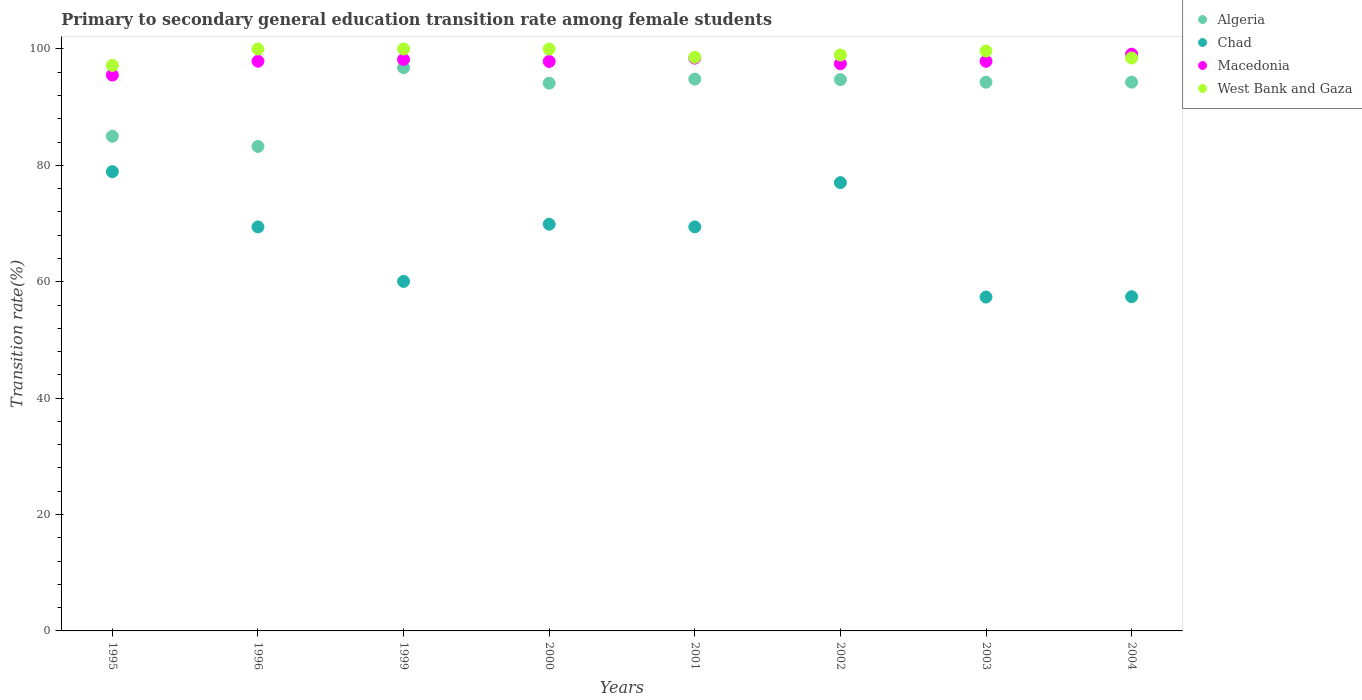How many different coloured dotlines are there?
Give a very brief answer. 4. What is the transition rate in Macedonia in 1996?
Keep it short and to the point. 97.9. Across all years, what is the minimum transition rate in Macedonia?
Provide a short and direct response. 95.51. In which year was the transition rate in Macedonia minimum?
Give a very brief answer. 1995. What is the total transition rate in Algeria in the graph?
Your response must be concise. 737.31. What is the difference between the transition rate in Macedonia in 2001 and that in 2003?
Ensure brevity in your answer.  0.54. What is the difference between the transition rate in Chad in 1995 and the transition rate in Macedonia in 2001?
Provide a succinct answer. -19.51. What is the average transition rate in Algeria per year?
Ensure brevity in your answer.  92.16. In the year 1999, what is the difference between the transition rate in Macedonia and transition rate in Algeria?
Make the answer very short. 1.42. What is the ratio of the transition rate in Macedonia in 1995 to that in 2002?
Your answer should be very brief. 0.98. Is the transition rate in West Bank and Gaza in 1995 less than that in 2003?
Make the answer very short. Yes. Is the difference between the transition rate in Macedonia in 1999 and 2001 greater than the difference between the transition rate in Algeria in 1999 and 2001?
Provide a succinct answer. No. What is the difference between the highest and the lowest transition rate in Macedonia?
Ensure brevity in your answer.  3.59. Is it the case that in every year, the sum of the transition rate in Chad and transition rate in West Bank and Gaza  is greater than the sum of transition rate in Algeria and transition rate in Macedonia?
Keep it short and to the point. No. Is it the case that in every year, the sum of the transition rate in Chad and transition rate in West Bank and Gaza  is greater than the transition rate in Algeria?
Give a very brief answer. Yes. Does the transition rate in Algeria monotonically increase over the years?
Give a very brief answer. No. Is the transition rate in Macedonia strictly greater than the transition rate in Chad over the years?
Give a very brief answer. Yes. Is the transition rate in Chad strictly less than the transition rate in Algeria over the years?
Offer a terse response. Yes. How many years are there in the graph?
Your response must be concise. 8. What is the difference between two consecutive major ticks on the Y-axis?
Your answer should be compact. 20. Are the values on the major ticks of Y-axis written in scientific E-notation?
Offer a very short reply. No. Does the graph contain any zero values?
Your answer should be compact. No. How are the legend labels stacked?
Your answer should be very brief. Vertical. What is the title of the graph?
Your answer should be very brief. Primary to secondary general education transition rate among female students. What is the label or title of the X-axis?
Your response must be concise. Years. What is the label or title of the Y-axis?
Make the answer very short. Transition rate(%). What is the Transition rate(%) of Algeria in 1995?
Keep it short and to the point. 85. What is the Transition rate(%) in Chad in 1995?
Give a very brief answer. 78.92. What is the Transition rate(%) of Macedonia in 1995?
Offer a very short reply. 95.51. What is the Transition rate(%) in West Bank and Gaza in 1995?
Keep it short and to the point. 97.18. What is the Transition rate(%) of Algeria in 1996?
Your response must be concise. 83.25. What is the Transition rate(%) in Chad in 1996?
Your response must be concise. 69.42. What is the Transition rate(%) in Macedonia in 1996?
Make the answer very short. 97.9. What is the Transition rate(%) of Algeria in 1999?
Give a very brief answer. 96.78. What is the Transition rate(%) of Chad in 1999?
Your answer should be compact. 60.06. What is the Transition rate(%) in Macedonia in 1999?
Provide a succinct answer. 98.2. What is the Transition rate(%) in West Bank and Gaza in 1999?
Offer a very short reply. 100. What is the Transition rate(%) in Algeria in 2000?
Your answer should be compact. 94.12. What is the Transition rate(%) in Chad in 2000?
Your response must be concise. 69.89. What is the Transition rate(%) in Macedonia in 2000?
Give a very brief answer. 97.86. What is the Transition rate(%) in Algeria in 2001?
Provide a succinct answer. 94.82. What is the Transition rate(%) of Chad in 2001?
Keep it short and to the point. 69.43. What is the Transition rate(%) of Macedonia in 2001?
Your response must be concise. 98.43. What is the Transition rate(%) in West Bank and Gaza in 2001?
Offer a terse response. 98.57. What is the Transition rate(%) in Algeria in 2002?
Offer a very short reply. 94.74. What is the Transition rate(%) of Chad in 2002?
Offer a very short reply. 77.03. What is the Transition rate(%) of Macedonia in 2002?
Provide a short and direct response. 97.47. What is the Transition rate(%) in West Bank and Gaza in 2002?
Offer a terse response. 98.96. What is the Transition rate(%) in Algeria in 2003?
Offer a terse response. 94.29. What is the Transition rate(%) of Chad in 2003?
Keep it short and to the point. 57.37. What is the Transition rate(%) in Macedonia in 2003?
Offer a very short reply. 97.88. What is the Transition rate(%) of West Bank and Gaza in 2003?
Offer a terse response. 99.65. What is the Transition rate(%) in Algeria in 2004?
Keep it short and to the point. 94.3. What is the Transition rate(%) in Chad in 2004?
Offer a terse response. 57.43. What is the Transition rate(%) of Macedonia in 2004?
Make the answer very short. 99.1. What is the Transition rate(%) of West Bank and Gaza in 2004?
Make the answer very short. 98.45. Across all years, what is the maximum Transition rate(%) of Algeria?
Offer a terse response. 96.78. Across all years, what is the maximum Transition rate(%) in Chad?
Your answer should be very brief. 78.92. Across all years, what is the maximum Transition rate(%) of Macedonia?
Ensure brevity in your answer.  99.1. Across all years, what is the maximum Transition rate(%) of West Bank and Gaza?
Your answer should be very brief. 100. Across all years, what is the minimum Transition rate(%) in Algeria?
Keep it short and to the point. 83.25. Across all years, what is the minimum Transition rate(%) of Chad?
Your answer should be compact. 57.37. Across all years, what is the minimum Transition rate(%) in Macedonia?
Your answer should be very brief. 95.51. Across all years, what is the minimum Transition rate(%) of West Bank and Gaza?
Your answer should be very brief. 97.18. What is the total Transition rate(%) in Algeria in the graph?
Make the answer very short. 737.31. What is the total Transition rate(%) in Chad in the graph?
Make the answer very short. 539.56. What is the total Transition rate(%) of Macedonia in the graph?
Your answer should be very brief. 782.35. What is the total Transition rate(%) of West Bank and Gaza in the graph?
Make the answer very short. 792.82. What is the difference between the Transition rate(%) in Chad in 1995 and that in 1996?
Ensure brevity in your answer.  9.5. What is the difference between the Transition rate(%) in Macedonia in 1995 and that in 1996?
Give a very brief answer. -2.39. What is the difference between the Transition rate(%) in West Bank and Gaza in 1995 and that in 1996?
Your answer should be compact. -2.82. What is the difference between the Transition rate(%) of Algeria in 1995 and that in 1999?
Ensure brevity in your answer.  -11.78. What is the difference between the Transition rate(%) in Chad in 1995 and that in 1999?
Give a very brief answer. 18.86. What is the difference between the Transition rate(%) in Macedonia in 1995 and that in 1999?
Provide a succinct answer. -2.68. What is the difference between the Transition rate(%) of West Bank and Gaza in 1995 and that in 1999?
Offer a terse response. -2.82. What is the difference between the Transition rate(%) of Algeria in 1995 and that in 2000?
Your response must be concise. -9.12. What is the difference between the Transition rate(%) of Chad in 1995 and that in 2000?
Offer a terse response. 9.03. What is the difference between the Transition rate(%) in Macedonia in 1995 and that in 2000?
Offer a terse response. -2.35. What is the difference between the Transition rate(%) in West Bank and Gaza in 1995 and that in 2000?
Offer a terse response. -2.82. What is the difference between the Transition rate(%) of Algeria in 1995 and that in 2001?
Provide a succinct answer. -9.82. What is the difference between the Transition rate(%) of Chad in 1995 and that in 2001?
Offer a terse response. 9.49. What is the difference between the Transition rate(%) of Macedonia in 1995 and that in 2001?
Your response must be concise. -2.92. What is the difference between the Transition rate(%) of West Bank and Gaza in 1995 and that in 2001?
Keep it short and to the point. -1.4. What is the difference between the Transition rate(%) of Algeria in 1995 and that in 2002?
Your answer should be compact. -9.73. What is the difference between the Transition rate(%) in Chad in 1995 and that in 2002?
Offer a very short reply. 1.88. What is the difference between the Transition rate(%) of Macedonia in 1995 and that in 2002?
Offer a terse response. -1.96. What is the difference between the Transition rate(%) in West Bank and Gaza in 1995 and that in 2002?
Keep it short and to the point. -1.79. What is the difference between the Transition rate(%) in Algeria in 1995 and that in 2003?
Give a very brief answer. -9.29. What is the difference between the Transition rate(%) of Chad in 1995 and that in 2003?
Your answer should be compact. 21.55. What is the difference between the Transition rate(%) of Macedonia in 1995 and that in 2003?
Make the answer very short. -2.37. What is the difference between the Transition rate(%) in West Bank and Gaza in 1995 and that in 2003?
Offer a very short reply. -2.48. What is the difference between the Transition rate(%) in Algeria in 1995 and that in 2004?
Your answer should be very brief. -9.3. What is the difference between the Transition rate(%) in Chad in 1995 and that in 2004?
Offer a terse response. 21.48. What is the difference between the Transition rate(%) in Macedonia in 1995 and that in 2004?
Keep it short and to the point. -3.59. What is the difference between the Transition rate(%) in West Bank and Gaza in 1995 and that in 2004?
Offer a very short reply. -1.28. What is the difference between the Transition rate(%) in Algeria in 1996 and that in 1999?
Your answer should be compact. -13.53. What is the difference between the Transition rate(%) in Chad in 1996 and that in 1999?
Provide a short and direct response. 9.36. What is the difference between the Transition rate(%) in Macedonia in 1996 and that in 1999?
Give a very brief answer. -0.3. What is the difference between the Transition rate(%) in West Bank and Gaza in 1996 and that in 1999?
Your response must be concise. 0. What is the difference between the Transition rate(%) of Algeria in 1996 and that in 2000?
Ensure brevity in your answer.  -10.87. What is the difference between the Transition rate(%) of Chad in 1996 and that in 2000?
Offer a terse response. -0.47. What is the difference between the Transition rate(%) of Macedonia in 1996 and that in 2000?
Offer a terse response. 0.04. What is the difference between the Transition rate(%) in Algeria in 1996 and that in 2001?
Your response must be concise. -11.57. What is the difference between the Transition rate(%) in Chad in 1996 and that in 2001?
Your answer should be compact. -0.01. What is the difference between the Transition rate(%) in Macedonia in 1996 and that in 2001?
Offer a very short reply. -0.53. What is the difference between the Transition rate(%) in West Bank and Gaza in 1996 and that in 2001?
Offer a very short reply. 1.43. What is the difference between the Transition rate(%) in Algeria in 1996 and that in 2002?
Give a very brief answer. -11.48. What is the difference between the Transition rate(%) in Chad in 1996 and that in 2002?
Offer a terse response. -7.61. What is the difference between the Transition rate(%) in Macedonia in 1996 and that in 2002?
Make the answer very short. 0.43. What is the difference between the Transition rate(%) of West Bank and Gaza in 1996 and that in 2002?
Ensure brevity in your answer.  1.04. What is the difference between the Transition rate(%) in Algeria in 1996 and that in 2003?
Your answer should be compact. -11.04. What is the difference between the Transition rate(%) of Chad in 1996 and that in 2003?
Offer a very short reply. 12.05. What is the difference between the Transition rate(%) in Macedonia in 1996 and that in 2003?
Ensure brevity in your answer.  0.01. What is the difference between the Transition rate(%) in West Bank and Gaza in 1996 and that in 2003?
Ensure brevity in your answer.  0.35. What is the difference between the Transition rate(%) in Algeria in 1996 and that in 2004?
Give a very brief answer. -11.05. What is the difference between the Transition rate(%) of Chad in 1996 and that in 2004?
Give a very brief answer. 11.99. What is the difference between the Transition rate(%) in Macedonia in 1996 and that in 2004?
Make the answer very short. -1.2. What is the difference between the Transition rate(%) in West Bank and Gaza in 1996 and that in 2004?
Offer a terse response. 1.55. What is the difference between the Transition rate(%) in Algeria in 1999 and that in 2000?
Provide a succinct answer. 2.66. What is the difference between the Transition rate(%) in Chad in 1999 and that in 2000?
Give a very brief answer. -9.83. What is the difference between the Transition rate(%) of Macedonia in 1999 and that in 2000?
Provide a short and direct response. 0.34. What is the difference between the Transition rate(%) in West Bank and Gaza in 1999 and that in 2000?
Keep it short and to the point. 0. What is the difference between the Transition rate(%) of Algeria in 1999 and that in 2001?
Your answer should be very brief. 1.96. What is the difference between the Transition rate(%) of Chad in 1999 and that in 2001?
Make the answer very short. -9.37. What is the difference between the Transition rate(%) in Macedonia in 1999 and that in 2001?
Your response must be concise. -0.23. What is the difference between the Transition rate(%) of West Bank and Gaza in 1999 and that in 2001?
Provide a succinct answer. 1.43. What is the difference between the Transition rate(%) in Algeria in 1999 and that in 2002?
Provide a short and direct response. 2.04. What is the difference between the Transition rate(%) of Chad in 1999 and that in 2002?
Your answer should be very brief. -16.98. What is the difference between the Transition rate(%) of Macedonia in 1999 and that in 2002?
Your answer should be compact. 0.73. What is the difference between the Transition rate(%) of West Bank and Gaza in 1999 and that in 2002?
Provide a short and direct response. 1.04. What is the difference between the Transition rate(%) in Algeria in 1999 and that in 2003?
Offer a terse response. 2.49. What is the difference between the Transition rate(%) in Chad in 1999 and that in 2003?
Offer a very short reply. 2.69. What is the difference between the Transition rate(%) in Macedonia in 1999 and that in 2003?
Your answer should be very brief. 0.31. What is the difference between the Transition rate(%) in West Bank and Gaza in 1999 and that in 2003?
Provide a short and direct response. 0.35. What is the difference between the Transition rate(%) of Algeria in 1999 and that in 2004?
Keep it short and to the point. 2.48. What is the difference between the Transition rate(%) in Chad in 1999 and that in 2004?
Offer a terse response. 2.63. What is the difference between the Transition rate(%) in Macedonia in 1999 and that in 2004?
Ensure brevity in your answer.  -0.91. What is the difference between the Transition rate(%) in West Bank and Gaza in 1999 and that in 2004?
Ensure brevity in your answer.  1.55. What is the difference between the Transition rate(%) of Algeria in 2000 and that in 2001?
Offer a very short reply. -0.7. What is the difference between the Transition rate(%) of Chad in 2000 and that in 2001?
Your response must be concise. 0.46. What is the difference between the Transition rate(%) of Macedonia in 2000 and that in 2001?
Keep it short and to the point. -0.57. What is the difference between the Transition rate(%) in West Bank and Gaza in 2000 and that in 2001?
Give a very brief answer. 1.43. What is the difference between the Transition rate(%) of Algeria in 2000 and that in 2002?
Keep it short and to the point. -0.62. What is the difference between the Transition rate(%) of Chad in 2000 and that in 2002?
Make the answer very short. -7.15. What is the difference between the Transition rate(%) in Macedonia in 2000 and that in 2002?
Make the answer very short. 0.39. What is the difference between the Transition rate(%) in West Bank and Gaza in 2000 and that in 2002?
Provide a succinct answer. 1.04. What is the difference between the Transition rate(%) of Algeria in 2000 and that in 2003?
Provide a short and direct response. -0.17. What is the difference between the Transition rate(%) in Chad in 2000 and that in 2003?
Your answer should be very brief. 12.52. What is the difference between the Transition rate(%) in Macedonia in 2000 and that in 2003?
Offer a terse response. -0.03. What is the difference between the Transition rate(%) of West Bank and Gaza in 2000 and that in 2003?
Ensure brevity in your answer.  0.35. What is the difference between the Transition rate(%) of Algeria in 2000 and that in 2004?
Offer a terse response. -0.18. What is the difference between the Transition rate(%) in Chad in 2000 and that in 2004?
Provide a short and direct response. 12.46. What is the difference between the Transition rate(%) of Macedonia in 2000 and that in 2004?
Your answer should be compact. -1.24. What is the difference between the Transition rate(%) of West Bank and Gaza in 2000 and that in 2004?
Your answer should be very brief. 1.55. What is the difference between the Transition rate(%) of Algeria in 2001 and that in 2002?
Provide a succinct answer. 0.09. What is the difference between the Transition rate(%) in Chad in 2001 and that in 2002?
Your response must be concise. -7.6. What is the difference between the Transition rate(%) in Macedonia in 2001 and that in 2002?
Your response must be concise. 0.96. What is the difference between the Transition rate(%) of West Bank and Gaza in 2001 and that in 2002?
Your answer should be compact. -0.39. What is the difference between the Transition rate(%) of Algeria in 2001 and that in 2003?
Offer a terse response. 0.53. What is the difference between the Transition rate(%) in Chad in 2001 and that in 2003?
Your answer should be very brief. 12.06. What is the difference between the Transition rate(%) of Macedonia in 2001 and that in 2003?
Your answer should be compact. 0.54. What is the difference between the Transition rate(%) in West Bank and Gaza in 2001 and that in 2003?
Ensure brevity in your answer.  -1.08. What is the difference between the Transition rate(%) of Algeria in 2001 and that in 2004?
Offer a very short reply. 0.53. What is the difference between the Transition rate(%) in Chad in 2001 and that in 2004?
Keep it short and to the point. 12. What is the difference between the Transition rate(%) in Macedonia in 2001 and that in 2004?
Give a very brief answer. -0.67. What is the difference between the Transition rate(%) in West Bank and Gaza in 2001 and that in 2004?
Your answer should be very brief. 0.12. What is the difference between the Transition rate(%) of Algeria in 2002 and that in 2003?
Provide a short and direct response. 0.45. What is the difference between the Transition rate(%) of Chad in 2002 and that in 2003?
Offer a very short reply. 19.66. What is the difference between the Transition rate(%) of Macedonia in 2002 and that in 2003?
Make the answer very short. -0.41. What is the difference between the Transition rate(%) of West Bank and Gaza in 2002 and that in 2003?
Offer a very short reply. -0.69. What is the difference between the Transition rate(%) of Algeria in 2002 and that in 2004?
Give a very brief answer. 0.44. What is the difference between the Transition rate(%) in Chad in 2002 and that in 2004?
Ensure brevity in your answer.  19.6. What is the difference between the Transition rate(%) in Macedonia in 2002 and that in 2004?
Keep it short and to the point. -1.63. What is the difference between the Transition rate(%) of West Bank and Gaza in 2002 and that in 2004?
Provide a succinct answer. 0.51. What is the difference between the Transition rate(%) in Algeria in 2003 and that in 2004?
Your answer should be very brief. -0.01. What is the difference between the Transition rate(%) of Chad in 2003 and that in 2004?
Offer a terse response. -0.06. What is the difference between the Transition rate(%) of Macedonia in 2003 and that in 2004?
Make the answer very short. -1.22. What is the difference between the Transition rate(%) in West Bank and Gaza in 2003 and that in 2004?
Keep it short and to the point. 1.2. What is the difference between the Transition rate(%) in Algeria in 1995 and the Transition rate(%) in Chad in 1996?
Your answer should be compact. 15.58. What is the difference between the Transition rate(%) of Algeria in 1995 and the Transition rate(%) of Macedonia in 1996?
Give a very brief answer. -12.9. What is the difference between the Transition rate(%) in Algeria in 1995 and the Transition rate(%) in West Bank and Gaza in 1996?
Your answer should be very brief. -15. What is the difference between the Transition rate(%) in Chad in 1995 and the Transition rate(%) in Macedonia in 1996?
Make the answer very short. -18.98. What is the difference between the Transition rate(%) in Chad in 1995 and the Transition rate(%) in West Bank and Gaza in 1996?
Offer a terse response. -21.08. What is the difference between the Transition rate(%) of Macedonia in 1995 and the Transition rate(%) of West Bank and Gaza in 1996?
Offer a terse response. -4.49. What is the difference between the Transition rate(%) of Algeria in 1995 and the Transition rate(%) of Chad in 1999?
Give a very brief answer. 24.94. What is the difference between the Transition rate(%) of Algeria in 1995 and the Transition rate(%) of Macedonia in 1999?
Your answer should be very brief. -13.19. What is the difference between the Transition rate(%) of Algeria in 1995 and the Transition rate(%) of West Bank and Gaza in 1999?
Your answer should be very brief. -15. What is the difference between the Transition rate(%) in Chad in 1995 and the Transition rate(%) in Macedonia in 1999?
Offer a very short reply. -19.28. What is the difference between the Transition rate(%) of Chad in 1995 and the Transition rate(%) of West Bank and Gaza in 1999?
Provide a succinct answer. -21.08. What is the difference between the Transition rate(%) in Macedonia in 1995 and the Transition rate(%) in West Bank and Gaza in 1999?
Offer a terse response. -4.49. What is the difference between the Transition rate(%) of Algeria in 1995 and the Transition rate(%) of Chad in 2000?
Provide a short and direct response. 15.12. What is the difference between the Transition rate(%) in Algeria in 1995 and the Transition rate(%) in Macedonia in 2000?
Offer a very short reply. -12.86. What is the difference between the Transition rate(%) of Algeria in 1995 and the Transition rate(%) of West Bank and Gaza in 2000?
Offer a terse response. -15. What is the difference between the Transition rate(%) in Chad in 1995 and the Transition rate(%) in Macedonia in 2000?
Offer a terse response. -18.94. What is the difference between the Transition rate(%) in Chad in 1995 and the Transition rate(%) in West Bank and Gaza in 2000?
Keep it short and to the point. -21.08. What is the difference between the Transition rate(%) in Macedonia in 1995 and the Transition rate(%) in West Bank and Gaza in 2000?
Offer a terse response. -4.49. What is the difference between the Transition rate(%) in Algeria in 1995 and the Transition rate(%) in Chad in 2001?
Your response must be concise. 15.57. What is the difference between the Transition rate(%) of Algeria in 1995 and the Transition rate(%) of Macedonia in 2001?
Provide a succinct answer. -13.42. What is the difference between the Transition rate(%) of Algeria in 1995 and the Transition rate(%) of West Bank and Gaza in 2001?
Offer a terse response. -13.57. What is the difference between the Transition rate(%) of Chad in 1995 and the Transition rate(%) of Macedonia in 2001?
Your response must be concise. -19.51. What is the difference between the Transition rate(%) of Chad in 1995 and the Transition rate(%) of West Bank and Gaza in 2001?
Provide a succinct answer. -19.66. What is the difference between the Transition rate(%) of Macedonia in 1995 and the Transition rate(%) of West Bank and Gaza in 2001?
Your answer should be compact. -3.06. What is the difference between the Transition rate(%) in Algeria in 1995 and the Transition rate(%) in Chad in 2002?
Provide a succinct answer. 7.97. What is the difference between the Transition rate(%) in Algeria in 1995 and the Transition rate(%) in Macedonia in 2002?
Offer a terse response. -12.47. What is the difference between the Transition rate(%) in Algeria in 1995 and the Transition rate(%) in West Bank and Gaza in 2002?
Ensure brevity in your answer.  -13.96. What is the difference between the Transition rate(%) of Chad in 1995 and the Transition rate(%) of Macedonia in 2002?
Provide a succinct answer. -18.55. What is the difference between the Transition rate(%) in Chad in 1995 and the Transition rate(%) in West Bank and Gaza in 2002?
Provide a short and direct response. -20.05. What is the difference between the Transition rate(%) of Macedonia in 1995 and the Transition rate(%) of West Bank and Gaza in 2002?
Provide a succinct answer. -3.45. What is the difference between the Transition rate(%) in Algeria in 1995 and the Transition rate(%) in Chad in 2003?
Offer a very short reply. 27.63. What is the difference between the Transition rate(%) in Algeria in 1995 and the Transition rate(%) in Macedonia in 2003?
Provide a short and direct response. -12.88. What is the difference between the Transition rate(%) of Algeria in 1995 and the Transition rate(%) of West Bank and Gaza in 2003?
Provide a succinct answer. -14.65. What is the difference between the Transition rate(%) in Chad in 1995 and the Transition rate(%) in Macedonia in 2003?
Your answer should be compact. -18.97. What is the difference between the Transition rate(%) of Chad in 1995 and the Transition rate(%) of West Bank and Gaza in 2003?
Provide a succinct answer. -20.74. What is the difference between the Transition rate(%) of Macedonia in 1995 and the Transition rate(%) of West Bank and Gaza in 2003?
Make the answer very short. -4.14. What is the difference between the Transition rate(%) in Algeria in 1995 and the Transition rate(%) in Chad in 2004?
Offer a terse response. 27.57. What is the difference between the Transition rate(%) of Algeria in 1995 and the Transition rate(%) of Macedonia in 2004?
Give a very brief answer. -14.1. What is the difference between the Transition rate(%) in Algeria in 1995 and the Transition rate(%) in West Bank and Gaza in 2004?
Your answer should be very brief. -13.45. What is the difference between the Transition rate(%) in Chad in 1995 and the Transition rate(%) in Macedonia in 2004?
Provide a short and direct response. -20.19. What is the difference between the Transition rate(%) of Chad in 1995 and the Transition rate(%) of West Bank and Gaza in 2004?
Your answer should be very brief. -19.54. What is the difference between the Transition rate(%) in Macedonia in 1995 and the Transition rate(%) in West Bank and Gaza in 2004?
Your answer should be compact. -2.94. What is the difference between the Transition rate(%) of Algeria in 1996 and the Transition rate(%) of Chad in 1999?
Offer a terse response. 23.19. What is the difference between the Transition rate(%) in Algeria in 1996 and the Transition rate(%) in Macedonia in 1999?
Provide a short and direct response. -14.94. What is the difference between the Transition rate(%) in Algeria in 1996 and the Transition rate(%) in West Bank and Gaza in 1999?
Offer a very short reply. -16.75. What is the difference between the Transition rate(%) in Chad in 1996 and the Transition rate(%) in Macedonia in 1999?
Give a very brief answer. -28.77. What is the difference between the Transition rate(%) in Chad in 1996 and the Transition rate(%) in West Bank and Gaza in 1999?
Your response must be concise. -30.58. What is the difference between the Transition rate(%) of Macedonia in 1996 and the Transition rate(%) of West Bank and Gaza in 1999?
Make the answer very short. -2.1. What is the difference between the Transition rate(%) in Algeria in 1996 and the Transition rate(%) in Chad in 2000?
Offer a very short reply. 13.37. What is the difference between the Transition rate(%) of Algeria in 1996 and the Transition rate(%) of Macedonia in 2000?
Make the answer very short. -14.61. What is the difference between the Transition rate(%) in Algeria in 1996 and the Transition rate(%) in West Bank and Gaza in 2000?
Provide a succinct answer. -16.75. What is the difference between the Transition rate(%) of Chad in 1996 and the Transition rate(%) of Macedonia in 2000?
Keep it short and to the point. -28.44. What is the difference between the Transition rate(%) of Chad in 1996 and the Transition rate(%) of West Bank and Gaza in 2000?
Offer a very short reply. -30.58. What is the difference between the Transition rate(%) in Macedonia in 1996 and the Transition rate(%) in West Bank and Gaza in 2000?
Provide a short and direct response. -2.1. What is the difference between the Transition rate(%) in Algeria in 1996 and the Transition rate(%) in Chad in 2001?
Make the answer very short. 13.82. What is the difference between the Transition rate(%) of Algeria in 1996 and the Transition rate(%) of Macedonia in 2001?
Your response must be concise. -15.17. What is the difference between the Transition rate(%) in Algeria in 1996 and the Transition rate(%) in West Bank and Gaza in 2001?
Your answer should be compact. -15.32. What is the difference between the Transition rate(%) of Chad in 1996 and the Transition rate(%) of Macedonia in 2001?
Your response must be concise. -29.01. What is the difference between the Transition rate(%) of Chad in 1996 and the Transition rate(%) of West Bank and Gaza in 2001?
Your answer should be compact. -29.15. What is the difference between the Transition rate(%) in Macedonia in 1996 and the Transition rate(%) in West Bank and Gaza in 2001?
Your response must be concise. -0.67. What is the difference between the Transition rate(%) of Algeria in 1996 and the Transition rate(%) of Chad in 2002?
Your answer should be very brief. 6.22. What is the difference between the Transition rate(%) of Algeria in 1996 and the Transition rate(%) of Macedonia in 2002?
Your answer should be very brief. -14.22. What is the difference between the Transition rate(%) in Algeria in 1996 and the Transition rate(%) in West Bank and Gaza in 2002?
Provide a short and direct response. -15.71. What is the difference between the Transition rate(%) in Chad in 1996 and the Transition rate(%) in Macedonia in 2002?
Make the answer very short. -28.05. What is the difference between the Transition rate(%) of Chad in 1996 and the Transition rate(%) of West Bank and Gaza in 2002?
Provide a short and direct response. -29.54. What is the difference between the Transition rate(%) in Macedonia in 1996 and the Transition rate(%) in West Bank and Gaza in 2002?
Keep it short and to the point. -1.07. What is the difference between the Transition rate(%) in Algeria in 1996 and the Transition rate(%) in Chad in 2003?
Ensure brevity in your answer.  25.88. What is the difference between the Transition rate(%) in Algeria in 1996 and the Transition rate(%) in Macedonia in 2003?
Give a very brief answer. -14.63. What is the difference between the Transition rate(%) in Algeria in 1996 and the Transition rate(%) in West Bank and Gaza in 2003?
Provide a short and direct response. -16.4. What is the difference between the Transition rate(%) in Chad in 1996 and the Transition rate(%) in Macedonia in 2003?
Keep it short and to the point. -28.46. What is the difference between the Transition rate(%) of Chad in 1996 and the Transition rate(%) of West Bank and Gaza in 2003?
Your answer should be compact. -30.23. What is the difference between the Transition rate(%) in Macedonia in 1996 and the Transition rate(%) in West Bank and Gaza in 2003?
Provide a succinct answer. -1.76. What is the difference between the Transition rate(%) of Algeria in 1996 and the Transition rate(%) of Chad in 2004?
Your answer should be very brief. 25.82. What is the difference between the Transition rate(%) in Algeria in 1996 and the Transition rate(%) in Macedonia in 2004?
Offer a terse response. -15.85. What is the difference between the Transition rate(%) of Algeria in 1996 and the Transition rate(%) of West Bank and Gaza in 2004?
Your answer should be compact. -15.2. What is the difference between the Transition rate(%) in Chad in 1996 and the Transition rate(%) in Macedonia in 2004?
Keep it short and to the point. -29.68. What is the difference between the Transition rate(%) in Chad in 1996 and the Transition rate(%) in West Bank and Gaza in 2004?
Offer a terse response. -29.03. What is the difference between the Transition rate(%) in Macedonia in 1996 and the Transition rate(%) in West Bank and Gaza in 2004?
Ensure brevity in your answer.  -0.55. What is the difference between the Transition rate(%) of Algeria in 1999 and the Transition rate(%) of Chad in 2000?
Make the answer very short. 26.89. What is the difference between the Transition rate(%) in Algeria in 1999 and the Transition rate(%) in Macedonia in 2000?
Ensure brevity in your answer.  -1.08. What is the difference between the Transition rate(%) in Algeria in 1999 and the Transition rate(%) in West Bank and Gaza in 2000?
Offer a very short reply. -3.22. What is the difference between the Transition rate(%) of Chad in 1999 and the Transition rate(%) of Macedonia in 2000?
Your answer should be very brief. -37.8. What is the difference between the Transition rate(%) of Chad in 1999 and the Transition rate(%) of West Bank and Gaza in 2000?
Offer a very short reply. -39.94. What is the difference between the Transition rate(%) in Macedonia in 1999 and the Transition rate(%) in West Bank and Gaza in 2000?
Offer a terse response. -1.8. What is the difference between the Transition rate(%) of Algeria in 1999 and the Transition rate(%) of Chad in 2001?
Give a very brief answer. 27.35. What is the difference between the Transition rate(%) of Algeria in 1999 and the Transition rate(%) of Macedonia in 2001?
Your response must be concise. -1.65. What is the difference between the Transition rate(%) in Algeria in 1999 and the Transition rate(%) in West Bank and Gaza in 2001?
Keep it short and to the point. -1.79. What is the difference between the Transition rate(%) in Chad in 1999 and the Transition rate(%) in Macedonia in 2001?
Offer a very short reply. -38.37. What is the difference between the Transition rate(%) of Chad in 1999 and the Transition rate(%) of West Bank and Gaza in 2001?
Offer a very short reply. -38.51. What is the difference between the Transition rate(%) in Macedonia in 1999 and the Transition rate(%) in West Bank and Gaza in 2001?
Make the answer very short. -0.38. What is the difference between the Transition rate(%) in Algeria in 1999 and the Transition rate(%) in Chad in 2002?
Make the answer very short. 19.75. What is the difference between the Transition rate(%) of Algeria in 1999 and the Transition rate(%) of Macedonia in 2002?
Keep it short and to the point. -0.69. What is the difference between the Transition rate(%) of Algeria in 1999 and the Transition rate(%) of West Bank and Gaza in 2002?
Your answer should be compact. -2.18. What is the difference between the Transition rate(%) in Chad in 1999 and the Transition rate(%) in Macedonia in 2002?
Keep it short and to the point. -37.41. What is the difference between the Transition rate(%) in Chad in 1999 and the Transition rate(%) in West Bank and Gaza in 2002?
Offer a very short reply. -38.91. What is the difference between the Transition rate(%) of Macedonia in 1999 and the Transition rate(%) of West Bank and Gaza in 2002?
Provide a short and direct response. -0.77. What is the difference between the Transition rate(%) in Algeria in 1999 and the Transition rate(%) in Chad in 2003?
Ensure brevity in your answer.  39.41. What is the difference between the Transition rate(%) in Algeria in 1999 and the Transition rate(%) in Macedonia in 2003?
Your answer should be very brief. -1.1. What is the difference between the Transition rate(%) of Algeria in 1999 and the Transition rate(%) of West Bank and Gaza in 2003?
Your answer should be compact. -2.87. What is the difference between the Transition rate(%) in Chad in 1999 and the Transition rate(%) in Macedonia in 2003?
Keep it short and to the point. -37.83. What is the difference between the Transition rate(%) in Chad in 1999 and the Transition rate(%) in West Bank and Gaza in 2003?
Ensure brevity in your answer.  -39.59. What is the difference between the Transition rate(%) of Macedonia in 1999 and the Transition rate(%) of West Bank and Gaza in 2003?
Your answer should be very brief. -1.46. What is the difference between the Transition rate(%) in Algeria in 1999 and the Transition rate(%) in Chad in 2004?
Provide a succinct answer. 39.35. What is the difference between the Transition rate(%) of Algeria in 1999 and the Transition rate(%) of Macedonia in 2004?
Ensure brevity in your answer.  -2.32. What is the difference between the Transition rate(%) in Algeria in 1999 and the Transition rate(%) in West Bank and Gaza in 2004?
Provide a succinct answer. -1.67. What is the difference between the Transition rate(%) in Chad in 1999 and the Transition rate(%) in Macedonia in 2004?
Your answer should be very brief. -39.04. What is the difference between the Transition rate(%) in Chad in 1999 and the Transition rate(%) in West Bank and Gaza in 2004?
Offer a terse response. -38.39. What is the difference between the Transition rate(%) of Macedonia in 1999 and the Transition rate(%) of West Bank and Gaza in 2004?
Provide a succinct answer. -0.26. What is the difference between the Transition rate(%) of Algeria in 2000 and the Transition rate(%) of Chad in 2001?
Offer a very short reply. 24.69. What is the difference between the Transition rate(%) in Algeria in 2000 and the Transition rate(%) in Macedonia in 2001?
Keep it short and to the point. -4.31. What is the difference between the Transition rate(%) of Algeria in 2000 and the Transition rate(%) of West Bank and Gaza in 2001?
Your response must be concise. -4.45. What is the difference between the Transition rate(%) in Chad in 2000 and the Transition rate(%) in Macedonia in 2001?
Make the answer very short. -28.54. What is the difference between the Transition rate(%) of Chad in 2000 and the Transition rate(%) of West Bank and Gaza in 2001?
Your response must be concise. -28.69. What is the difference between the Transition rate(%) of Macedonia in 2000 and the Transition rate(%) of West Bank and Gaza in 2001?
Offer a terse response. -0.71. What is the difference between the Transition rate(%) in Algeria in 2000 and the Transition rate(%) in Chad in 2002?
Provide a short and direct response. 17.09. What is the difference between the Transition rate(%) in Algeria in 2000 and the Transition rate(%) in Macedonia in 2002?
Give a very brief answer. -3.35. What is the difference between the Transition rate(%) in Algeria in 2000 and the Transition rate(%) in West Bank and Gaza in 2002?
Give a very brief answer. -4.84. What is the difference between the Transition rate(%) of Chad in 2000 and the Transition rate(%) of Macedonia in 2002?
Provide a succinct answer. -27.58. What is the difference between the Transition rate(%) in Chad in 2000 and the Transition rate(%) in West Bank and Gaza in 2002?
Provide a succinct answer. -29.08. What is the difference between the Transition rate(%) in Macedonia in 2000 and the Transition rate(%) in West Bank and Gaza in 2002?
Your answer should be very brief. -1.11. What is the difference between the Transition rate(%) in Algeria in 2000 and the Transition rate(%) in Chad in 2003?
Offer a very short reply. 36.75. What is the difference between the Transition rate(%) in Algeria in 2000 and the Transition rate(%) in Macedonia in 2003?
Keep it short and to the point. -3.76. What is the difference between the Transition rate(%) in Algeria in 2000 and the Transition rate(%) in West Bank and Gaza in 2003?
Provide a short and direct response. -5.53. What is the difference between the Transition rate(%) in Chad in 2000 and the Transition rate(%) in Macedonia in 2003?
Keep it short and to the point. -28. What is the difference between the Transition rate(%) in Chad in 2000 and the Transition rate(%) in West Bank and Gaza in 2003?
Offer a very short reply. -29.77. What is the difference between the Transition rate(%) of Macedonia in 2000 and the Transition rate(%) of West Bank and Gaza in 2003?
Offer a very short reply. -1.8. What is the difference between the Transition rate(%) in Algeria in 2000 and the Transition rate(%) in Chad in 2004?
Give a very brief answer. 36.69. What is the difference between the Transition rate(%) of Algeria in 2000 and the Transition rate(%) of Macedonia in 2004?
Keep it short and to the point. -4.98. What is the difference between the Transition rate(%) of Algeria in 2000 and the Transition rate(%) of West Bank and Gaza in 2004?
Provide a succinct answer. -4.33. What is the difference between the Transition rate(%) of Chad in 2000 and the Transition rate(%) of Macedonia in 2004?
Your answer should be very brief. -29.21. What is the difference between the Transition rate(%) of Chad in 2000 and the Transition rate(%) of West Bank and Gaza in 2004?
Provide a succinct answer. -28.57. What is the difference between the Transition rate(%) of Macedonia in 2000 and the Transition rate(%) of West Bank and Gaza in 2004?
Offer a very short reply. -0.6. What is the difference between the Transition rate(%) of Algeria in 2001 and the Transition rate(%) of Chad in 2002?
Provide a succinct answer. 17.79. What is the difference between the Transition rate(%) of Algeria in 2001 and the Transition rate(%) of Macedonia in 2002?
Offer a very short reply. -2.65. What is the difference between the Transition rate(%) of Algeria in 2001 and the Transition rate(%) of West Bank and Gaza in 2002?
Your answer should be compact. -4.14. What is the difference between the Transition rate(%) of Chad in 2001 and the Transition rate(%) of Macedonia in 2002?
Keep it short and to the point. -28.04. What is the difference between the Transition rate(%) of Chad in 2001 and the Transition rate(%) of West Bank and Gaza in 2002?
Offer a very short reply. -29.53. What is the difference between the Transition rate(%) in Macedonia in 2001 and the Transition rate(%) in West Bank and Gaza in 2002?
Offer a very short reply. -0.54. What is the difference between the Transition rate(%) of Algeria in 2001 and the Transition rate(%) of Chad in 2003?
Provide a succinct answer. 37.45. What is the difference between the Transition rate(%) of Algeria in 2001 and the Transition rate(%) of Macedonia in 2003?
Offer a terse response. -3.06. What is the difference between the Transition rate(%) of Algeria in 2001 and the Transition rate(%) of West Bank and Gaza in 2003?
Your answer should be very brief. -4.83. What is the difference between the Transition rate(%) in Chad in 2001 and the Transition rate(%) in Macedonia in 2003?
Offer a terse response. -28.45. What is the difference between the Transition rate(%) of Chad in 2001 and the Transition rate(%) of West Bank and Gaza in 2003?
Your answer should be compact. -30.22. What is the difference between the Transition rate(%) of Macedonia in 2001 and the Transition rate(%) of West Bank and Gaza in 2003?
Your answer should be very brief. -1.23. What is the difference between the Transition rate(%) in Algeria in 2001 and the Transition rate(%) in Chad in 2004?
Ensure brevity in your answer.  37.39. What is the difference between the Transition rate(%) in Algeria in 2001 and the Transition rate(%) in Macedonia in 2004?
Give a very brief answer. -4.28. What is the difference between the Transition rate(%) of Algeria in 2001 and the Transition rate(%) of West Bank and Gaza in 2004?
Your answer should be very brief. -3.63. What is the difference between the Transition rate(%) of Chad in 2001 and the Transition rate(%) of Macedonia in 2004?
Your answer should be compact. -29.67. What is the difference between the Transition rate(%) in Chad in 2001 and the Transition rate(%) in West Bank and Gaza in 2004?
Your response must be concise. -29.02. What is the difference between the Transition rate(%) in Macedonia in 2001 and the Transition rate(%) in West Bank and Gaza in 2004?
Make the answer very short. -0.03. What is the difference between the Transition rate(%) of Algeria in 2002 and the Transition rate(%) of Chad in 2003?
Keep it short and to the point. 37.37. What is the difference between the Transition rate(%) in Algeria in 2002 and the Transition rate(%) in Macedonia in 2003?
Offer a terse response. -3.15. What is the difference between the Transition rate(%) of Algeria in 2002 and the Transition rate(%) of West Bank and Gaza in 2003?
Your response must be concise. -4.92. What is the difference between the Transition rate(%) of Chad in 2002 and the Transition rate(%) of Macedonia in 2003?
Provide a succinct answer. -20.85. What is the difference between the Transition rate(%) in Chad in 2002 and the Transition rate(%) in West Bank and Gaza in 2003?
Offer a terse response. -22.62. What is the difference between the Transition rate(%) in Macedonia in 2002 and the Transition rate(%) in West Bank and Gaza in 2003?
Your answer should be very brief. -2.18. What is the difference between the Transition rate(%) in Algeria in 2002 and the Transition rate(%) in Chad in 2004?
Ensure brevity in your answer.  37.3. What is the difference between the Transition rate(%) in Algeria in 2002 and the Transition rate(%) in Macedonia in 2004?
Provide a succinct answer. -4.37. What is the difference between the Transition rate(%) in Algeria in 2002 and the Transition rate(%) in West Bank and Gaza in 2004?
Provide a short and direct response. -3.72. What is the difference between the Transition rate(%) of Chad in 2002 and the Transition rate(%) of Macedonia in 2004?
Keep it short and to the point. -22.07. What is the difference between the Transition rate(%) of Chad in 2002 and the Transition rate(%) of West Bank and Gaza in 2004?
Provide a succinct answer. -21.42. What is the difference between the Transition rate(%) of Macedonia in 2002 and the Transition rate(%) of West Bank and Gaza in 2004?
Provide a short and direct response. -0.98. What is the difference between the Transition rate(%) of Algeria in 2003 and the Transition rate(%) of Chad in 2004?
Provide a short and direct response. 36.86. What is the difference between the Transition rate(%) of Algeria in 2003 and the Transition rate(%) of Macedonia in 2004?
Make the answer very short. -4.81. What is the difference between the Transition rate(%) of Algeria in 2003 and the Transition rate(%) of West Bank and Gaza in 2004?
Offer a very short reply. -4.16. What is the difference between the Transition rate(%) of Chad in 2003 and the Transition rate(%) of Macedonia in 2004?
Provide a short and direct response. -41.73. What is the difference between the Transition rate(%) in Chad in 2003 and the Transition rate(%) in West Bank and Gaza in 2004?
Your response must be concise. -41.08. What is the difference between the Transition rate(%) in Macedonia in 2003 and the Transition rate(%) in West Bank and Gaza in 2004?
Make the answer very short. -0.57. What is the average Transition rate(%) in Algeria per year?
Offer a terse response. 92.16. What is the average Transition rate(%) in Chad per year?
Provide a short and direct response. 67.44. What is the average Transition rate(%) of Macedonia per year?
Your answer should be compact. 97.79. What is the average Transition rate(%) in West Bank and Gaza per year?
Provide a succinct answer. 99.1. In the year 1995, what is the difference between the Transition rate(%) of Algeria and Transition rate(%) of Chad?
Keep it short and to the point. 6.09. In the year 1995, what is the difference between the Transition rate(%) of Algeria and Transition rate(%) of Macedonia?
Keep it short and to the point. -10.51. In the year 1995, what is the difference between the Transition rate(%) of Algeria and Transition rate(%) of West Bank and Gaza?
Keep it short and to the point. -12.17. In the year 1995, what is the difference between the Transition rate(%) in Chad and Transition rate(%) in Macedonia?
Your answer should be compact. -16.6. In the year 1995, what is the difference between the Transition rate(%) of Chad and Transition rate(%) of West Bank and Gaza?
Your response must be concise. -18.26. In the year 1995, what is the difference between the Transition rate(%) in Macedonia and Transition rate(%) in West Bank and Gaza?
Provide a short and direct response. -1.66. In the year 1996, what is the difference between the Transition rate(%) of Algeria and Transition rate(%) of Chad?
Provide a succinct answer. 13.83. In the year 1996, what is the difference between the Transition rate(%) in Algeria and Transition rate(%) in Macedonia?
Your answer should be very brief. -14.65. In the year 1996, what is the difference between the Transition rate(%) of Algeria and Transition rate(%) of West Bank and Gaza?
Make the answer very short. -16.75. In the year 1996, what is the difference between the Transition rate(%) in Chad and Transition rate(%) in Macedonia?
Ensure brevity in your answer.  -28.48. In the year 1996, what is the difference between the Transition rate(%) of Chad and Transition rate(%) of West Bank and Gaza?
Your answer should be compact. -30.58. In the year 1996, what is the difference between the Transition rate(%) in Macedonia and Transition rate(%) in West Bank and Gaza?
Your response must be concise. -2.1. In the year 1999, what is the difference between the Transition rate(%) in Algeria and Transition rate(%) in Chad?
Ensure brevity in your answer.  36.72. In the year 1999, what is the difference between the Transition rate(%) in Algeria and Transition rate(%) in Macedonia?
Give a very brief answer. -1.42. In the year 1999, what is the difference between the Transition rate(%) of Algeria and Transition rate(%) of West Bank and Gaza?
Ensure brevity in your answer.  -3.22. In the year 1999, what is the difference between the Transition rate(%) of Chad and Transition rate(%) of Macedonia?
Keep it short and to the point. -38.14. In the year 1999, what is the difference between the Transition rate(%) of Chad and Transition rate(%) of West Bank and Gaza?
Keep it short and to the point. -39.94. In the year 1999, what is the difference between the Transition rate(%) of Macedonia and Transition rate(%) of West Bank and Gaza?
Provide a short and direct response. -1.8. In the year 2000, what is the difference between the Transition rate(%) of Algeria and Transition rate(%) of Chad?
Keep it short and to the point. 24.23. In the year 2000, what is the difference between the Transition rate(%) in Algeria and Transition rate(%) in Macedonia?
Your answer should be compact. -3.74. In the year 2000, what is the difference between the Transition rate(%) in Algeria and Transition rate(%) in West Bank and Gaza?
Make the answer very short. -5.88. In the year 2000, what is the difference between the Transition rate(%) in Chad and Transition rate(%) in Macedonia?
Ensure brevity in your answer.  -27.97. In the year 2000, what is the difference between the Transition rate(%) in Chad and Transition rate(%) in West Bank and Gaza?
Your answer should be compact. -30.11. In the year 2000, what is the difference between the Transition rate(%) of Macedonia and Transition rate(%) of West Bank and Gaza?
Offer a terse response. -2.14. In the year 2001, what is the difference between the Transition rate(%) of Algeria and Transition rate(%) of Chad?
Ensure brevity in your answer.  25.39. In the year 2001, what is the difference between the Transition rate(%) of Algeria and Transition rate(%) of Macedonia?
Your answer should be very brief. -3.6. In the year 2001, what is the difference between the Transition rate(%) of Algeria and Transition rate(%) of West Bank and Gaza?
Provide a succinct answer. -3.75. In the year 2001, what is the difference between the Transition rate(%) of Chad and Transition rate(%) of Macedonia?
Give a very brief answer. -29. In the year 2001, what is the difference between the Transition rate(%) in Chad and Transition rate(%) in West Bank and Gaza?
Ensure brevity in your answer.  -29.14. In the year 2001, what is the difference between the Transition rate(%) of Macedonia and Transition rate(%) of West Bank and Gaza?
Keep it short and to the point. -0.14. In the year 2002, what is the difference between the Transition rate(%) of Algeria and Transition rate(%) of Chad?
Your answer should be very brief. 17.7. In the year 2002, what is the difference between the Transition rate(%) in Algeria and Transition rate(%) in Macedonia?
Your answer should be compact. -2.73. In the year 2002, what is the difference between the Transition rate(%) of Algeria and Transition rate(%) of West Bank and Gaza?
Make the answer very short. -4.23. In the year 2002, what is the difference between the Transition rate(%) of Chad and Transition rate(%) of Macedonia?
Offer a very short reply. -20.44. In the year 2002, what is the difference between the Transition rate(%) of Chad and Transition rate(%) of West Bank and Gaza?
Give a very brief answer. -21.93. In the year 2002, what is the difference between the Transition rate(%) of Macedonia and Transition rate(%) of West Bank and Gaza?
Provide a succinct answer. -1.49. In the year 2003, what is the difference between the Transition rate(%) in Algeria and Transition rate(%) in Chad?
Offer a terse response. 36.92. In the year 2003, what is the difference between the Transition rate(%) of Algeria and Transition rate(%) of Macedonia?
Provide a short and direct response. -3.6. In the year 2003, what is the difference between the Transition rate(%) of Algeria and Transition rate(%) of West Bank and Gaza?
Ensure brevity in your answer.  -5.36. In the year 2003, what is the difference between the Transition rate(%) of Chad and Transition rate(%) of Macedonia?
Keep it short and to the point. -40.51. In the year 2003, what is the difference between the Transition rate(%) of Chad and Transition rate(%) of West Bank and Gaza?
Your answer should be very brief. -42.28. In the year 2003, what is the difference between the Transition rate(%) of Macedonia and Transition rate(%) of West Bank and Gaza?
Keep it short and to the point. -1.77. In the year 2004, what is the difference between the Transition rate(%) in Algeria and Transition rate(%) in Chad?
Keep it short and to the point. 36.87. In the year 2004, what is the difference between the Transition rate(%) in Algeria and Transition rate(%) in Macedonia?
Ensure brevity in your answer.  -4.8. In the year 2004, what is the difference between the Transition rate(%) of Algeria and Transition rate(%) of West Bank and Gaza?
Ensure brevity in your answer.  -4.15. In the year 2004, what is the difference between the Transition rate(%) in Chad and Transition rate(%) in Macedonia?
Make the answer very short. -41.67. In the year 2004, what is the difference between the Transition rate(%) in Chad and Transition rate(%) in West Bank and Gaza?
Provide a short and direct response. -41.02. In the year 2004, what is the difference between the Transition rate(%) of Macedonia and Transition rate(%) of West Bank and Gaza?
Offer a terse response. 0.65. What is the ratio of the Transition rate(%) of Algeria in 1995 to that in 1996?
Give a very brief answer. 1.02. What is the ratio of the Transition rate(%) of Chad in 1995 to that in 1996?
Your answer should be compact. 1.14. What is the ratio of the Transition rate(%) of Macedonia in 1995 to that in 1996?
Offer a terse response. 0.98. What is the ratio of the Transition rate(%) of West Bank and Gaza in 1995 to that in 1996?
Make the answer very short. 0.97. What is the ratio of the Transition rate(%) in Algeria in 1995 to that in 1999?
Your answer should be very brief. 0.88. What is the ratio of the Transition rate(%) in Chad in 1995 to that in 1999?
Offer a terse response. 1.31. What is the ratio of the Transition rate(%) of Macedonia in 1995 to that in 1999?
Your answer should be very brief. 0.97. What is the ratio of the Transition rate(%) of West Bank and Gaza in 1995 to that in 1999?
Provide a short and direct response. 0.97. What is the ratio of the Transition rate(%) of Algeria in 1995 to that in 2000?
Provide a short and direct response. 0.9. What is the ratio of the Transition rate(%) in Chad in 1995 to that in 2000?
Your answer should be compact. 1.13. What is the ratio of the Transition rate(%) in West Bank and Gaza in 1995 to that in 2000?
Your answer should be compact. 0.97. What is the ratio of the Transition rate(%) in Algeria in 1995 to that in 2001?
Provide a short and direct response. 0.9. What is the ratio of the Transition rate(%) of Chad in 1995 to that in 2001?
Your answer should be very brief. 1.14. What is the ratio of the Transition rate(%) in Macedonia in 1995 to that in 2001?
Offer a terse response. 0.97. What is the ratio of the Transition rate(%) of West Bank and Gaza in 1995 to that in 2001?
Ensure brevity in your answer.  0.99. What is the ratio of the Transition rate(%) in Algeria in 1995 to that in 2002?
Your answer should be very brief. 0.9. What is the ratio of the Transition rate(%) in Chad in 1995 to that in 2002?
Provide a short and direct response. 1.02. What is the ratio of the Transition rate(%) of Macedonia in 1995 to that in 2002?
Keep it short and to the point. 0.98. What is the ratio of the Transition rate(%) in West Bank and Gaza in 1995 to that in 2002?
Your answer should be very brief. 0.98. What is the ratio of the Transition rate(%) in Algeria in 1995 to that in 2003?
Provide a short and direct response. 0.9. What is the ratio of the Transition rate(%) of Chad in 1995 to that in 2003?
Ensure brevity in your answer.  1.38. What is the ratio of the Transition rate(%) of Macedonia in 1995 to that in 2003?
Provide a succinct answer. 0.98. What is the ratio of the Transition rate(%) in West Bank and Gaza in 1995 to that in 2003?
Ensure brevity in your answer.  0.98. What is the ratio of the Transition rate(%) in Algeria in 1995 to that in 2004?
Your answer should be compact. 0.9. What is the ratio of the Transition rate(%) in Chad in 1995 to that in 2004?
Make the answer very short. 1.37. What is the ratio of the Transition rate(%) of Macedonia in 1995 to that in 2004?
Your answer should be compact. 0.96. What is the ratio of the Transition rate(%) of West Bank and Gaza in 1995 to that in 2004?
Keep it short and to the point. 0.99. What is the ratio of the Transition rate(%) of Algeria in 1996 to that in 1999?
Offer a very short reply. 0.86. What is the ratio of the Transition rate(%) of Chad in 1996 to that in 1999?
Give a very brief answer. 1.16. What is the ratio of the Transition rate(%) in Algeria in 1996 to that in 2000?
Keep it short and to the point. 0.88. What is the ratio of the Transition rate(%) in Chad in 1996 to that in 2000?
Ensure brevity in your answer.  0.99. What is the ratio of the Transition rate(%) of Macedonia in 1996 to that in 2000?
Keep it short and to the point. 1. What is the ratio of the Transition rate(%) in Algeria in 1996 to that in 2001?
Make the answer very short. 0.88. What is the ratio of the Transition rate(%) of Macedonia in 1996 to that in 2001?
Provide a succinct answer. 0.99. What is the ratio of the Transition rate(%) of West Bank and Gaza in 1996 to that in 2001?
Offer a very short reply. 1.01. What is the ratio of the Transition rate(%) of Algeria in 1996 to that in 2002?
Provide a short and direct response. 0.88. What is the ratio of the Transition rate(%) in Chad in 1996 to that in 2002?
Provide a short and direct response. 0.9. What is the ratio of the Transition rate(%) in Macedonia in 1996 to that in 2002?
Your response must be concise. 1. What is the ratio of the Transition rate(%) of West Bank and Gaza in 1996 to that in 2002?
Your answer should be very brief. 1.01. What is the ratio of the Transition rate(%) of Algeria in 1996 to that in 2003?
Give a very brief answer. 0.88. What is the ratio of the Transition rate(%) of Chad in 1996 to that in 2003?
Provide a short and direct response. 1.21. What is the ratio of the Transition rate(%) in Macedonia in 1996 to that in 2003?
Ensure brevity in your answer.  1. What is the ratio of the Transition rate(%) of West Bank and Gaza in 1996 to that in 2003?
Keep it short and to the point. 1. What is the ratio of the Transition rate(%) of Algeria in 1996 to that in 2004?
Provide a short and direct response. 0.88. What is the ratio of the Transition rate(%) of Chad in 1996 to that in 2004?
Your response must be concise. 1.21. What is the ratio of the Transition rate(%) of Macedonia in 1996 to that in 2004?
Offer a terse response. 0.99. What is the ratio of the Transition rate(%) of West Bank and Gaza in 1996 to that in 2004?
Give a very brief answer. 1.02. What is the ratio of the Transition rate(%) of Algeria in 1999 to that in 2000?
Offer a terse response. 1.03. What is the ratio of the Transition rate(%) in Chad in 1999 to that in 2000?
Your answer should be compact. 0.86. What is the ratio of the Transition rate(%) of Macedonia in 1999 to that in 2000?
Ensure brevity in your answer.  1. What is the ratio of the Transition rate(%) of Algeria in 1999 to that in 2001?
Your answer should be very brief. 1.02. What is the ratio of the Transition rate(%) in Chad in 1999 to that in 2001?
Keep it short and to the point. 0.86. What is the ratio of the Transition rate(%) in West Bank and Gaza in 1999 to that in 2001?
Ensure brevity in your answer.  1.01. What is the ratio of the Transition rate(%) in Algeria in 1999 to that in 2002?
Offer a very short reply. 1.02. What is the ratio of the Transition rate(%) in Chad in 1999 to that in 2002?
Give a very brief answer. 0.78. What is the ratio of the Transition rate(%) of Macedonia in 1999 to that in 2002?
Your answer should be compact. 1.01. What is the ratio of the Transition rate(%) in West Bank and Gaza in 1999 to that in 2002?
Provide a short and direct response. 1.01. What is the ratio of the Transition rate(%) of Algeria in 1999 to that in 2003?
Give a very brief answer. 1.03. What is the ratio of the Transition rate(%) in Chad in 1999 to that in 2003?
Offer a very short reply. 1.05. What is the ratio of the Transition rate(%) in West Bank and Gaza in 1999 to that in 2003?
Your answer should be very brief. 1. What is the ratio of the Transition rate(%) of Algeria in 1999 to that in 2004?
Provide a short and direct response. 1.03. What is the ratio of the Transition rate(%) of Chad in 1999 to that in 2004?
Ensure brevity in your answer.  1.05. What is the ratio of the Transition rate(%) of Macedonia in 1999 to that in 2004?
Make the answer very short. 0.99. What is the ratio of the Transition rate(%) in West Bank and Gaza in 1999 to that in 2004?
Your answer should be compact. 1.02. What is the ratio of the Transition rate(%) of Chad in 2000 to that in 2001?
Provide a succinct answer. 1.01. What is the ratio of the Transition rate(%) of Macedonia in 2000 to that in 2001?
Offer a terse response. 0.99. What is the ratio of the Transition rate(%) in West Bank and Gaza in 2000 to that in 2001?
Your response must be concise. 1.01. What is the ratio of the Transition rate(%) of Chad in 2000 to that in 2002?
Keep it short and to the point. 0.91. What is the ratio of the Transition rate(%) in West Bank and Gaza in 2000 to that in 2002?
Provide a short and direct response. 1.01. What is the ratio of the Transition rate(%) of Algeria in 2000 to that in 2003?
Offer a very short reply. 1. What is the ratio of the Transition rate(%) of Chad in 2000 to that in 2003?
Offer a terse response. 1.22. What is the ratio of the Transition rate(%) in Macedonia in 2000 to that in 2003?
Your answer should be very brief. 1. What is the ratio of the Transition rate(%) of West Bank and Gaza in 2000 to that in 2003?
Make the answer very short. 1. What is the ratio of the Transition rate(%) in Algeria in 2000 to that in 2004?
Keep it short and to the point. 1. What is the ratio of the Transition rate(%) in Chad in 2000 to that in 2004?
Offer a very short reply. 1.22. What is the ratio of the Transition rate(%) of Macedonia in 2000 to that in 2004?
Offer a very short reply. 0.99. What is the ratio of the Transition rate(%) in West Bank and Gaza in 2000 to that in 2004?
Your response must be concise. 1.02. What is the ratio of the Transition rate(%) in Algeria in 2001 to that in 2002?
Provide a short and direct response. 1. What is the ratio of the Transition rate(%) in Chad in 2001 to that in 2002?
Your response must be concise. 0.9. What is the ratio of the Transition rate(%) of Macedonia in 2001 to that in 2002?
Your response must be concise. 1.01. What is the ratio of the Transition rate(%) in West Bank and Gaza in 2001 to that in 2002?
Provide a short and direct response. 1. What is the ratio of the Transition rate(%) of Algeria in 2001 to that in 2003?
Your answer should be very brief. 1.01. What is the ratio of the Transition rate(%) in Chad in 2001 to that in 2003?
Make the answer very short. 1.21. What is the ratio of the Transition rate(%) in Algeria in 2001 to that in 2004?
Provide a succinct answer. 1.01. What is the ratio of the Transition rate(%) of Chad in 2001 to that in 2004?
Your response must be concise. 1.21. What is the ratio of the Transition rate(%) in Macedonia in 2001 to that in 2004?
Provide a short and direct response. 0.99. What is the ratio of the Transition rate(%) of Chad in 2002 to that in 2003?
Give a very brief answer. 1.34. What is the ratio of the Transition rate(%) in Macedonia in 2002 to that in 2003?
Your answer should be compact. 1. What is the ratio of the Transition rate(%) of Algeria in 2002 to that in 2004?
Your answer should be very brief. 1. What is the ratio of the Transition rate(%) of Chad in 2002 to that in 2004?
Provide a succinct answer. 1.34. What is the ratio of the Transition rate(%) in Macedonia in 2002 to that in 2004?
Offer a terse response. 0.98. What is the ratio of the Transition rate(%) in West Bank and Gaza in 2003 to that in 2004?
Keep it short and to the point. 1.01. What is the difference between the highest and the second highest Transition rate(%) of Algeria?
Offer a very short reply. 1.96. What is the difference between the highest and the second highest Transition rate(%) in Chad?
Make the answer very short. 1.88. What is the difference between the highest and the second highest Transition rate(%) of Macedonia?
Make the answer very short. 0.67. What is the difference between the highest and the second highest Transition rate(%) of West Bank and Gaza?
Make the answer very short. 0. What is the difference between the highest and the lowest Transition rate(%) in Algeria?
Your answer should be compact. 13.53. What is the difference between the highest and the lowest Transition rate(%) of Chad?
Provide a short and direct response. 21.55. What is the difference between the highest and the lowest Transition rate(%) in Macedonia?
Make the answer very short. 3.59. What is the difference between the highest and the lowest Transition rate(%) of West Bank and Gaza?
Ensure brevity in your answer.  2.82. 